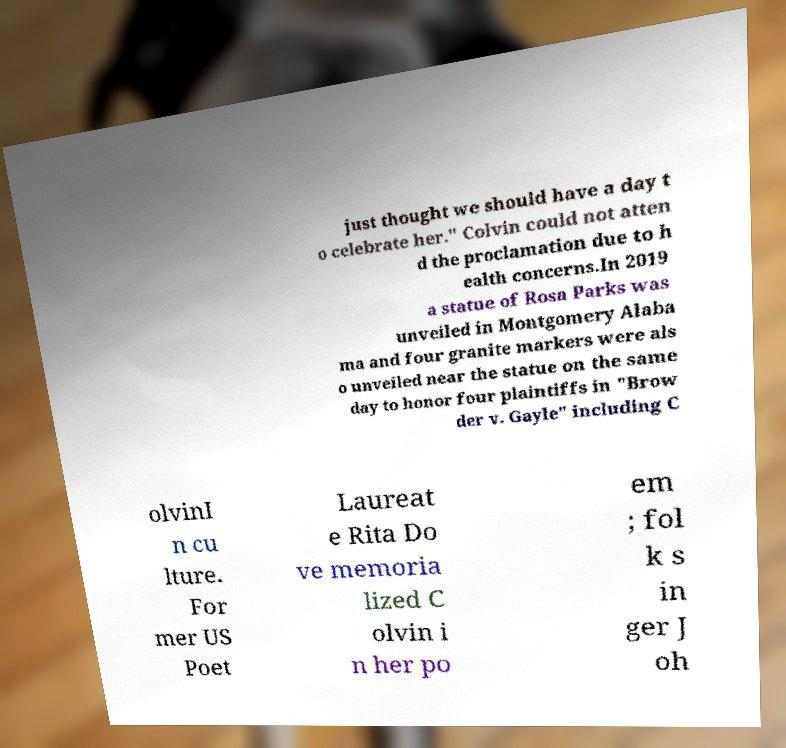Please identify and transcribe the text found in this image. just thought we should have a day t o celebrate her." Colvin could not atten d the proclamation due to h ealth concerns.In 2019 a statue of Rosa Parks was unveiled in Montgomery Alaba ma and four granite markers were als o unveiled near the statue on the same day to honor four plaintiffs in "Brow der v. Gayle" including C olvinI n cu lture. For mer US Poet Laureat e Rita Do ve memoria lized C olvin i n her po em ; fol k s in ger J oh 